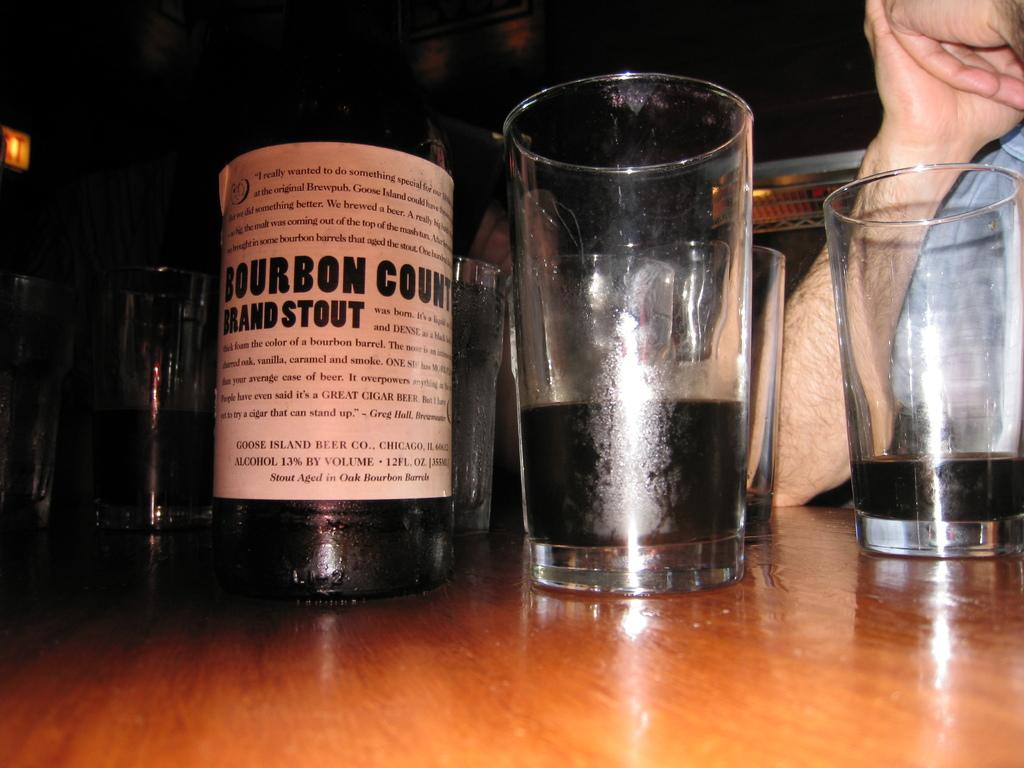<image>
Provide a brief description of the given image. A bottle of Bourbon Country Brand Stout next to an almost empty glass. 